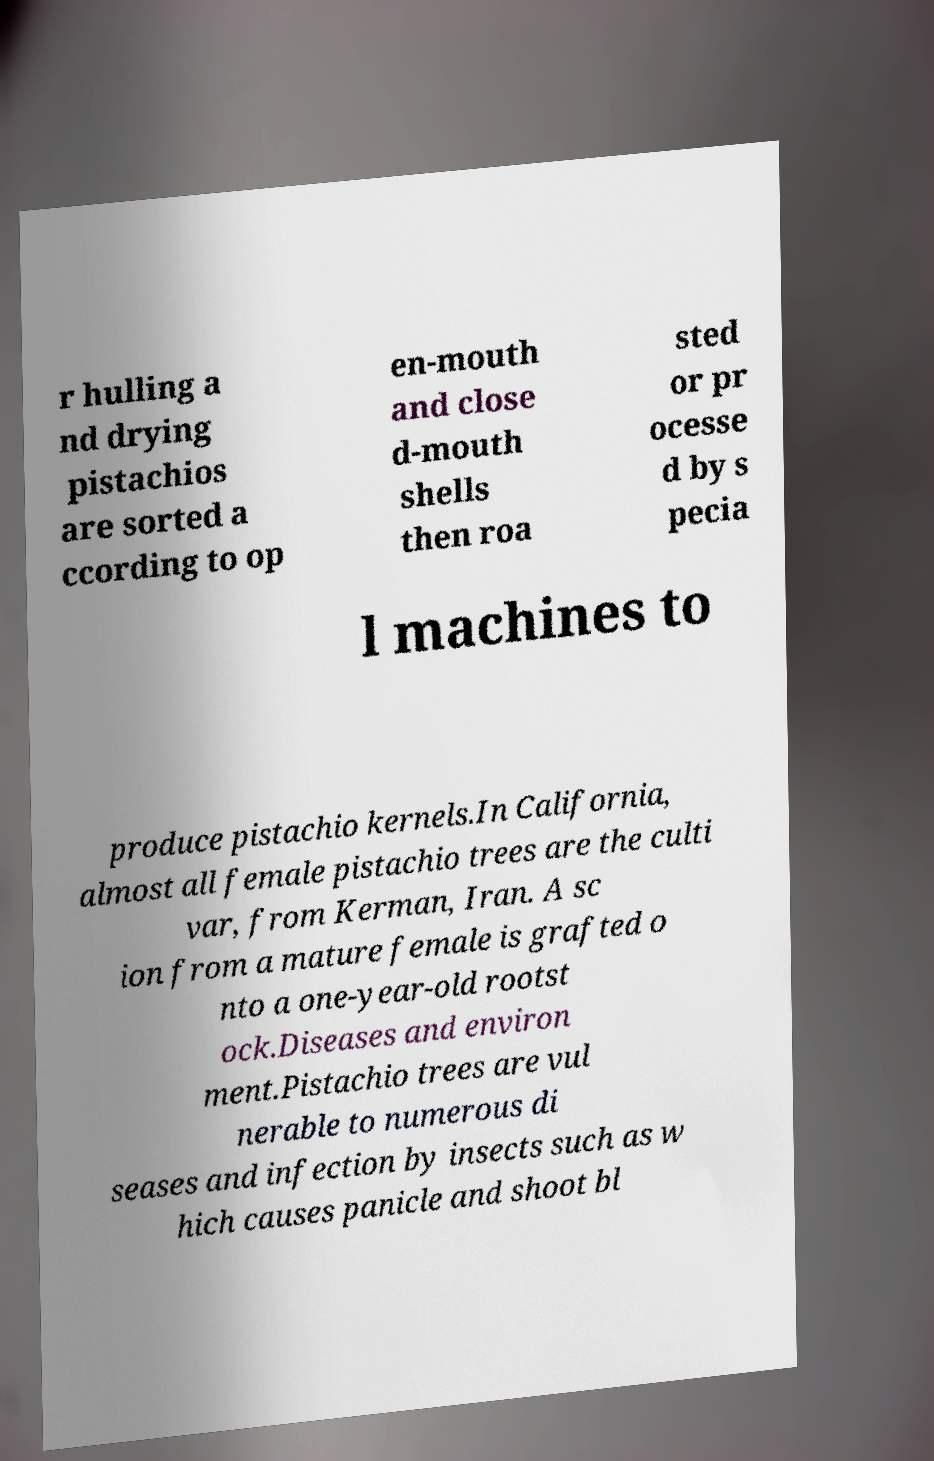Could you assist in decoding the text presented in this image and type it out clearly? r hulling a nd drying pistachios are sorted a ccording to op en-mouth and close d-mouth shells then roa sted or pr ocesse d by s pecia l machines to produce pistachio kernels.In California, almost all female pistachio trees are the culti var, from Kerman, Iran. A sc ion from a mature female is grafted o nto a one-year-old rootst ock.Diseases and environ ment.Pistachio trees are vul nerable to numerous di seases and infection by insects such as w hich causes panicle and shoot bl 